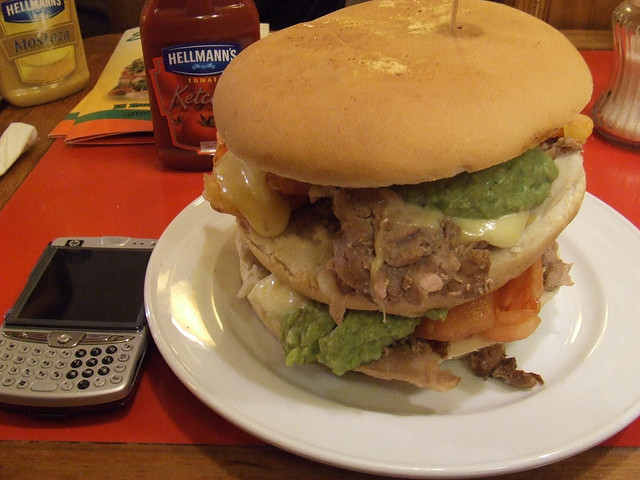<image>Where are the sesame seeds? There are no sesame seeds in the image. Where are the sesame seeds? I don't know where the sesame seeds are. They are nowhere to be found. 